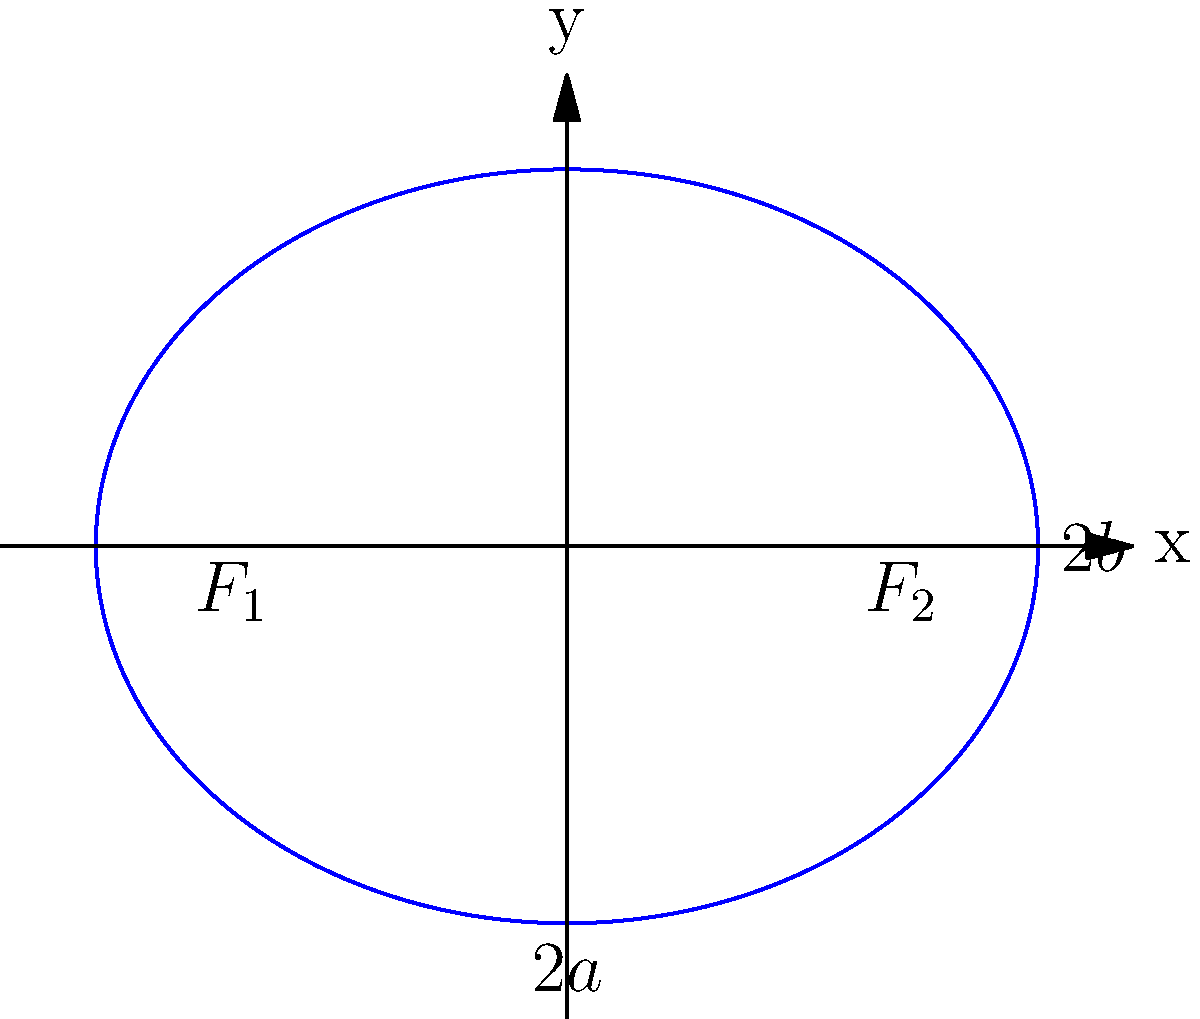As a tennis enthusiast, you're designing an elliptical stadium. The stadium's shape is represented by the equation $\frac{x^2}{25} + \frac{y^2}{16} = 1$. What is the area of this elliptical stadium in square units? Let's approach this step-by-step:

1) The general equation of an ellipse is $\frac{x^2}{a^2} + \frac{y^2}{b^2} = 1$, where $a$ and $b$ are the lengths of the semi-major and semi-minor axes respectively.

2) Comparing our equation $\frac{x^2}{25} + \frac{y^2}{16} = 1$ with the general form, we can see that:
   $a^2 = 25$ and $b^2 = 16$

3) Therefore:
   $a = \sqrt{25} = 5$
   $b = \sqrt{16} = 4$

4) The area of an ellipse is given by the formula: $A = \pi ab$

5) Substituting our values:
   $A = \pi(5)(4)$
   $A = 20\pi$

6) Therefore, the area of the elliptical stadium is $20\pi$ square units.
Answer: $20\pi$ square units 